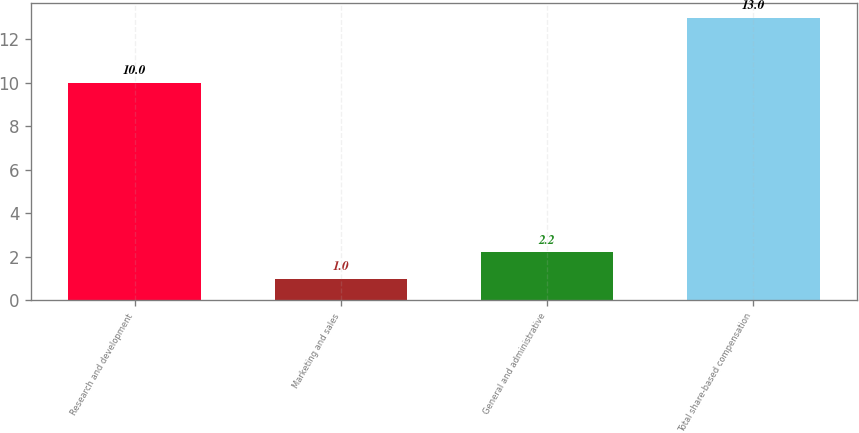Convert chart. <chart><loc_0><loc_0><loc_500><loc_500><bar_chart><fcel>Research and development<fcel>Marketing and sales<fcel>General and administrative<fcel>Total share-based compensation<nl><fcel>10<fcel>1<fcel>2.2<fcel>13<nl></chart> 